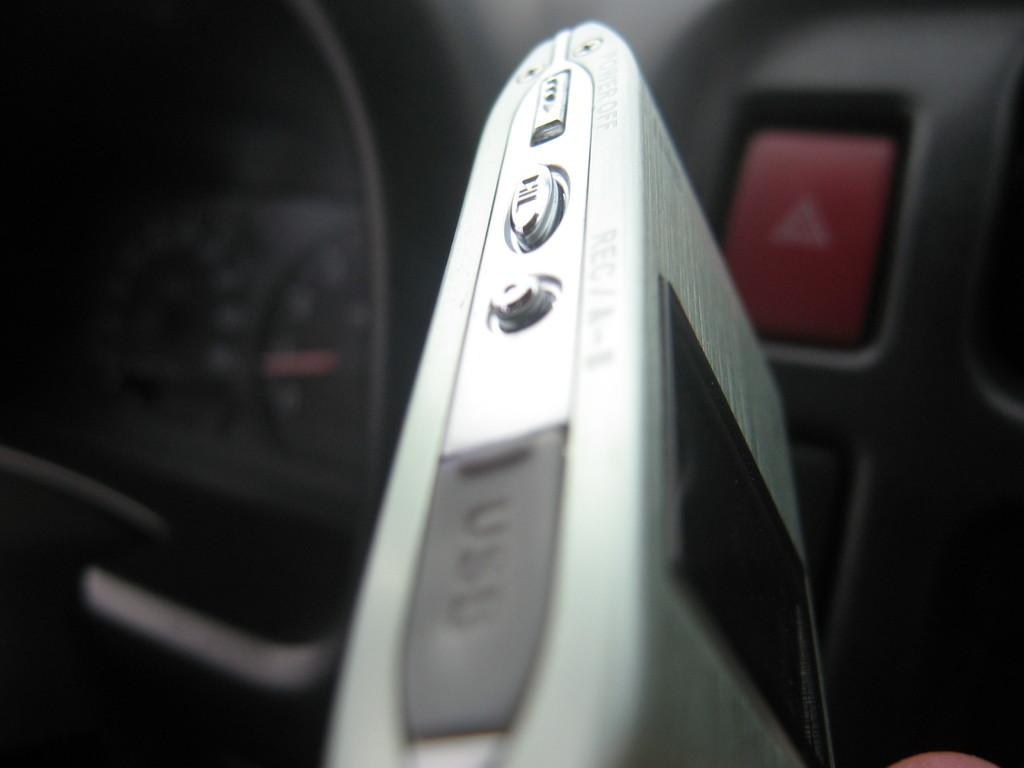What type of electronic device is visible in the image? The specific type of electronic device is not mentioned, but it is present in the image. What part of a vehicle can be seen in the image? The inner part of a vehicle is visible in the image. Can you see a horse combing its mane in the image? No, there is no horse or comb present in the image. 